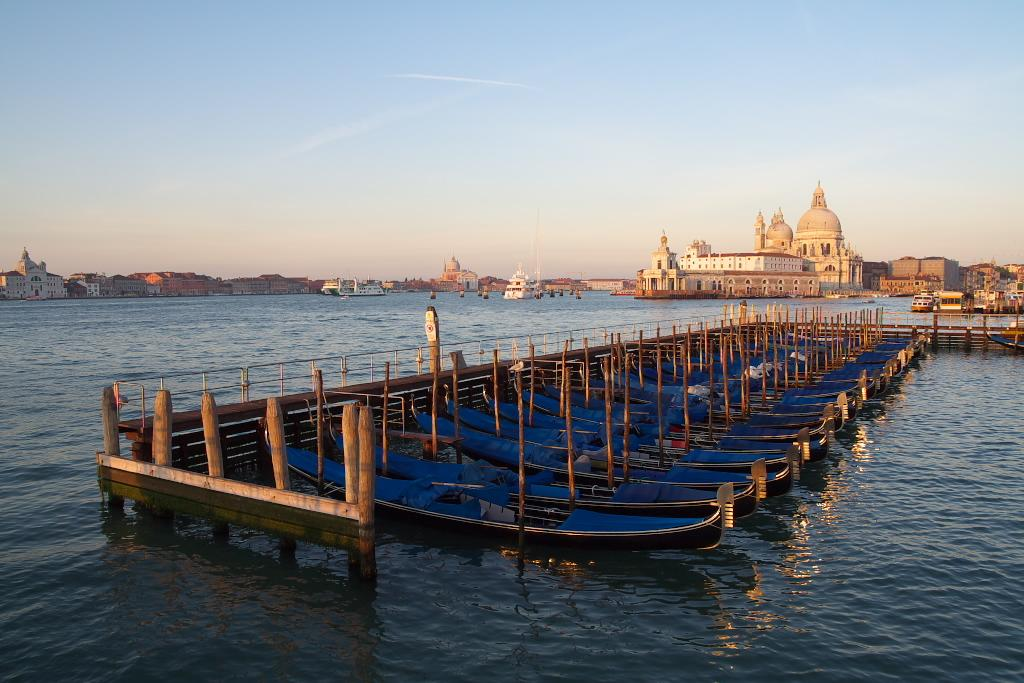What is the main subject of the image? The main subject of the image is boats. Where are the boats located in the image? The boats are on the water in the center of the image. What can be seen in the background of the image? There are buildings and the sky visible in the background of the image. What type of design can be seen on the boats in the image? There is no specific design mentioned in the facts, so we cannot determine the design of the boats from the image. 